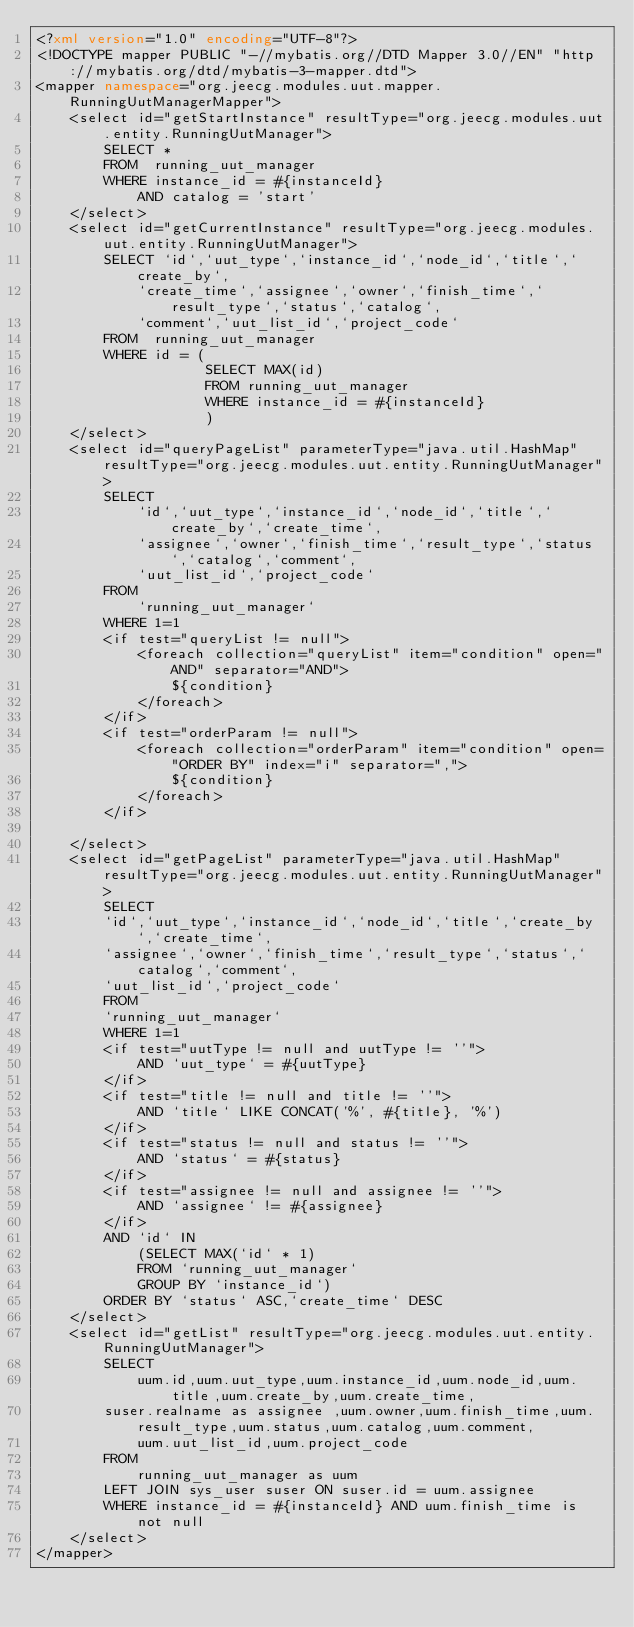Convert code to text. <code><loc_0><loc_0><loc_500><loc_500><_XML_><?xml version="1.0" encoding="UTF-8"?>
<!DOCTYPE mapper PUBLIC "-//mybatis.org//DTD Mapper 3.0//EN" "http://mybatis.org/dtd/mybatis-3-mapper.dtd">
<mapper namespace="org.jeecg.modules.uut.mapper.RunningUutManagerMapper">
	<select id="getStartInstance" resultType="org.jeecg.modules.uut.entity.RunningUutManager">
		SELECT * 
		FROM  running_uut_manager
		WHERE instance_id = #{instanceId}
			AND catalog = 'start'
	</select>
	<select id="getCurrentInstance" resultType="org.jeecg.modules.uut.entity.RunningUutManager">
		SELECT `id`,`uut_type`,`instance_id`,`node_id`,`title`,`create_by`,
			`create_time`,`assignee`,`owner`,`finish_time`,`result_type`,`status`,`catalog`,
			`comment`,`uut_list_id`,`project_code` 
		FROM  running_uut_manager
		WHERE id = (
					SELECT MAX(id) 
					FROM running_uut_manager 
					WHERE instance_id = #{instanceId}
					)
	</select>
	<select id="queryPageList" parameterType="java.util.HashMap" resultType="org.jeecg.modules.uut.entity.RunningUutManager">
		SELECT
			`id`,`uut_type`,`instance_id`,`node_id`,`title`,`create_by`,`create_time`,
		    `assignee`,`owner`,`finish_time`,`result_type`,`status`,`catalog`,`comment`,
		    `uut_list_id`,`project_code`
		FROM
			`running_uut_manager`
		WHERE 1=1
		<if test="queryList != null">
			<foreach collection="queryList" item="condition" open="AND" separator="AND">
				${condition}
			</foreach>
		</if>
		<if test="orderParam != null">
			<foreach collection="orderParam" item="condition" open="ORDER BY" index="i" separator=",">
				${condition}
			</foreach>
		</if>

	</select>
	<select id="getPageList" parameterType="java.util.HashMap" resultType="org.jeecg.modules.uut.entity.RunningUutManager">
		SELECT
		`id`,`uut_type`,`instance_id`,`node_id`,`title`,`create_by`,`create_time`,
		`assignee`,`owner`,`finish_time`,`result_type`,`status`,`catalog`,`comment`,
		`uut_list_id`,`project_code`
		FROM
		`running_uut_manager`
		WHERE 1=1
		<if test="uutType != null and uutType != ''">
			AND `uut_type` = #{uutType}
		</if>
		<if test="title != null and title != ''">
			AND `title` LIKE CONCAT('%', #{title}, '%')
		</if>
		<if test="status != null and status != ''">
			AND `status` = #{status}
		</if>
		<if test="assignee != null and assignee != ''">
			AND `assignee` != #{assignee}
		</if>
		AND `id` IN
		    (SELECT MAX(`id` * 1)
			FROM `running_uut_manager`
			GROUP BY `instance_id`)
		ORDER BY `status` ASC,`create_time` DESC
	</select>
    <select id="getList" resultType="org.jeecg.modules.uut.entity.RunningUutManager">
		SELECT
			uum.id,uum.uut_type,uum.instance_id,uum.node_id,uum.title,uum.create_by,uum.create_time,
		suser.realname as assignee ,uum.owner,uum.finish_time,uum.result_type,uum.status,uum.catalog,uum.comment,
			uum.uut_list_id,uum.project_code
		FROM
			running_uut_manager as uum
		LEFT JOIN sys_user suser ON suser.id = uum.assignee
		WHERE instance_id = #{instanceId} AND uum.finish_time is not null
	</select>
</mapper></code> 